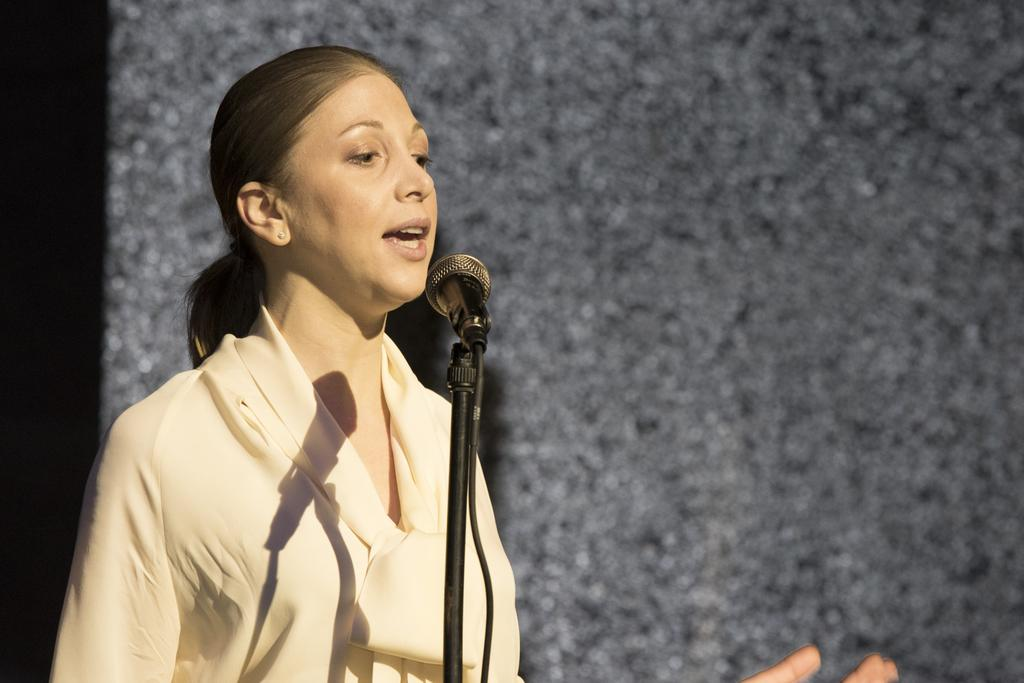Who is the main subject in the image? There is a lady in the image. What object is in front of the lady? There is a microphone with a mic stand in front of the lady. What can be seen behind the lady? There is a wall in the background of the image. What type of guide is the lady holding in the image? There is no guide present in the image; the lady is standing in front of a microphone with a mic stand. 